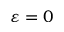<formula> <loc_0><loc_0><loc_500><loc_500>\varepsilon = 0</formula> 